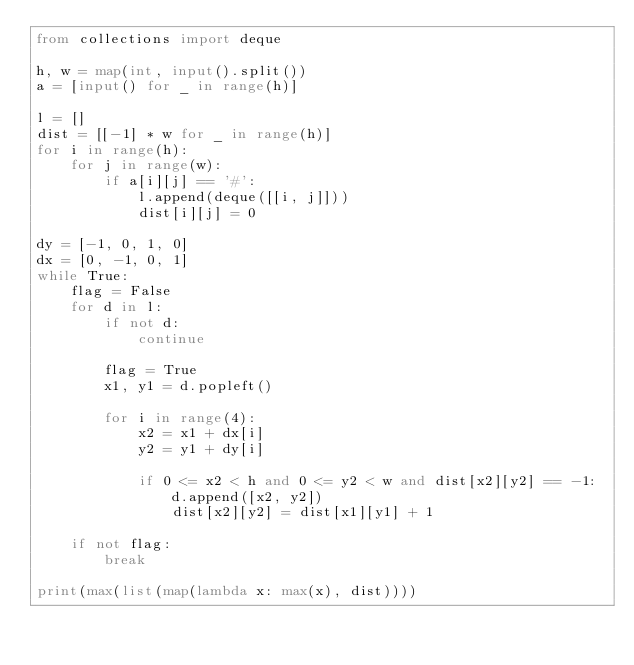Convert code to text. <code><loc_0><loc_0><loc_500><loc_500><_Python_>from collections import deque

h, w = map(int, input().split())
a = [input() for _ in range(h)]

l = []
dist = [[-1] * w for _ in range(h)]
for i in range(h):
    for j in range(w):
        if a[i][j] == '#':
            l.append(deque([[i, j]]))
            dist[i][j] = 0

dy = [-1, 0, 1, 0]
dx = [0, -1, 0, 1]
while True:
    flag = False
    for d in l:
        if not d:
            continue

        flag = True
        x1, y1 = d.popleft()

        for i in range(4):
            x2 = x1 + dx[i]
            y2 = y1 + dy[i]

            if 0 <= x2 < h and 0 <= y2 < w and dist[x2][y2] == -1:
                d.append([x2, y2])
                dist[x2][y2] = dist[x1][y1] + 1
    
    if not flag:
        break

print(max(list(map(lambda x: max(x), dist))))</code> 